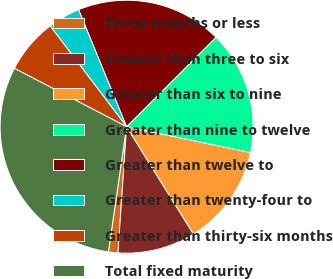<chart> <loc_0><loc_0><loc_500><loc_500><pie_chart><fcel>Three months or less<fcel>Greater than three to six<fcel>Greater than six to nine<fcel>Greater than nine to twelve<fcel>Greater than twelve to<fcel>Greater than twenty-four to<fcel>Greater than thirty-six months<fcel>Total fixed maturity<nl><fcel>1.21%<fcel>9.95%<fcel>12.86%<fcel>15.78%<fcel>18.69%<fcel>4.13%<fcel>7.04%<fcel>30.34%<nl></chart> 